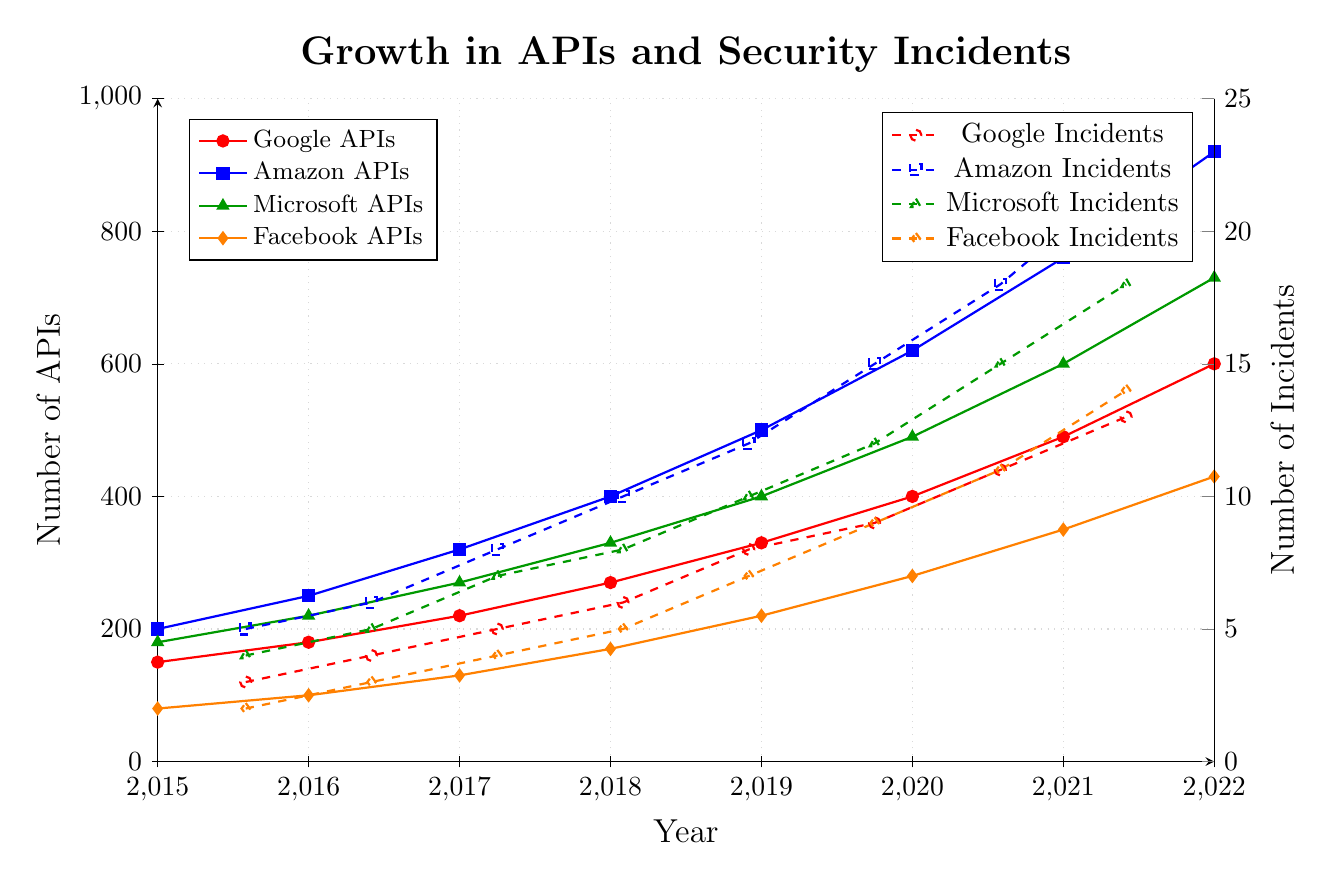What is the total number of APIs exposed by Facebook and Microsoft in 2020? In 2020, Facebook exposed 280 APIs and Microsoft exposed 490 APIs. Summing these gives 280 + 490 = 770.
Answer: 770 Which company had the highest number of security incidents in 2019? In 2019, Google had 8 incidents, Amazon had 12 incidents, Microsoft had 10 incidents, and Facebook had 7 incidents. Amazon had the highest number of incidents.
Answer: Amazon By how many did the number of APIs exposed by Google increase from 2017 to 2021? In 2017, Google had 220 APIs and by 2021, they had 490 APIs. The increase is 490 - 220 = 270.
Answer: 270 What is the overall trend in the number of security incidents from 2015 to 2022 for all companies? The number of security incidents for all companies shows an increasing trend from 2015 to 2022. For every company, the incidents increased steadily over the years.
Answer: Increasing Which company had a higher number of APIs compared to Facebook consistently from 2015 to 2022? From 2015 to 2022, all other companies (Google, Amazon, Microsoft) had a consistently higher number of APIs compared to Facebook.
Answer: Google, Amazon, Microsoft In what year did Amazon surpass 500 APIs, and what were their security incidents that year? Amazon surpassed 500 APIs in 2019 with 500 APIs and had 12 security incidents that year.
Answer: 2019 with 12 incidents Between which consecutive years did Microsoft see the highest increase in the number of APIs? Between 2020 and 2021, Microsoft saw an increase from 490 to 600 APIs, which is an increase of 110 APIs.
Answer: 2020 to 2021 On average, how many security incidents did Google report per year from 2015 to 2022? Google reported a total of 3 + 4 + 5 + 6 + 8 + 9 + 11 + 13 = 59 incidents over 8 years. The average per year is 59 / 8 = 7.375.
Answer: 7.375 What is the relation between the number of APIs and the number of security incidents for Amazon in 2018? In 2018, Amazon exposed 400 APIs and reported 10 security incidents. The API count is significantly higher while incidences are much lower, indicative of a potential correlation but not necessarily direct proportionality.
Answer: High APIs but lower incidents ratio Which company had the most consistent rate of increase in the number of APIs from 2015 to 2022? All companies show an increase, but Microsoft and Facebook appear to have a more consistent and steady increase when compared visually against fluctuating increases in Google and Amazon.
Answer: Microsoft, Facebook 